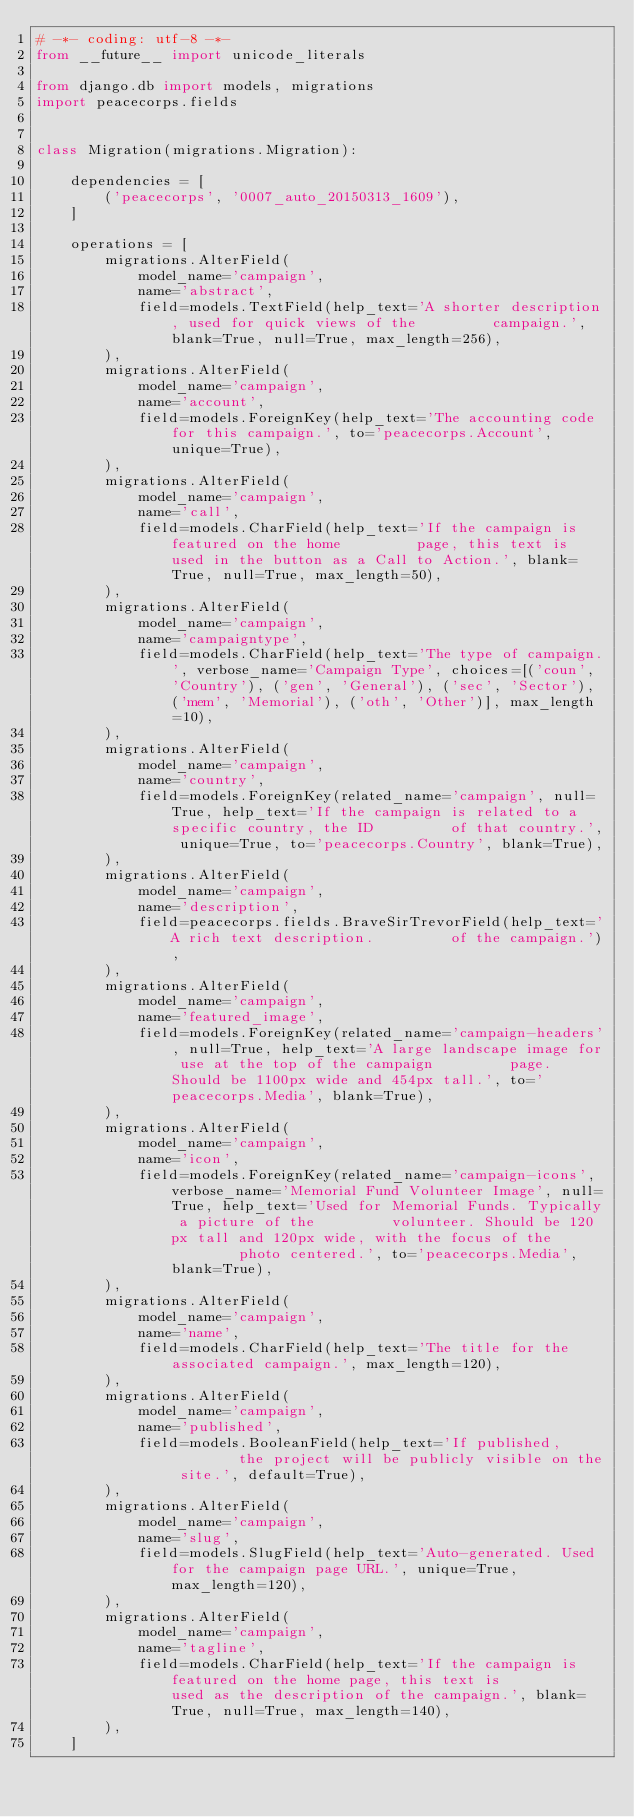<code> <loc_0><loc_0><loc_500><loc_500><_Python_># -*- coding: utf-8 -*-
from __future__ import unicode_literals

from django.db import models, migrations
import peacecorps.fields


class Migration(migrations.Migration):

    dependencies = [
        ('peacecorps', '0007_auto_20150313_1609'),
    ]

    operations = [
        migrations.AlterField(
            model_name='campaign',
            name='abstract',
            field=models.TextField(help_text='A shorter description, used for quick views of the         campaign.', blank=True, null=True, max_length=256),
        ),
        migrations.AlterField(
            model_name='campaign',
            name='account',
            field=models.ForeignKey(help_text='The accounting code for this campaign.', to='peacecorps.Account', unique=True),
        ),
        migrations.AlterField(
            model_name='campaign',
            name='call',
            field=models.CharField(help_text='If the campaign is featured on the home         page, this text is used in the button as a Call to Action.', blank=True, null=True, max_length=50),
        ),
        migrations.AlterField(
            model_name='campaign',
            name='campaigntype',
            field=models.CharField(help_text='The type of campaign.', verbose_name='Campaign Type', choices=[('coun', 'Country'), ('gen', 'General'), ('sec', 'Sector'), ('mem', 'Memorial'), ('oth', 'Other')], max_length=10),
        ),
        migrations.AlterField(
            model_name='campaign',
            name='country',
            field=models.ForeignKey(related_name='campaign', null=True, help_text='If the campaign is related to a specific country, the ID         of that country.', unique=True, to='peacecorps.Country', blank=True),
        ),
        migrations.AlterField(
            model_name='campaign',
            name='description',
            field=peacecorps.fields.BraveSirTrevorField(help_text='A rich text description.         of the campaign.'),
        ),
        migrations.AlterField(
            model_name='campaign',
            name='featured_image',
            field=models.ForeignKey(related_name='campaign-headers', null=True, help_text='A large landscape image for use at the top of the campaign         page. Should be 1100px wide and 454px tall.', to='peacecorps.Media', blank=True),
        ),
        migrations.AlterField(
            model_name='campaign',
            name='icon',
            field=models.ForeignKey(related_name='campaign-icons', verbose_name='Memorial Fund Volunteer Image', null=True, help_text='Used for Memorial Funds. Typically a picture of the         volunteer. Should be 120px tall and 120px wide, with the focus of the         photo centered.', to='peacecorps.Media', blank=True),
        ),
        migrations.AlterField(
            model_name='campaign',
            name='name',
            field=models.CharField(help_text='The title for the associated campaign.', max_length=120),
        ),
        migrations.AlterField(
            model_name='campaign',
            name='published',
            field=models.BooleanField(help_text='If published,         the project will be publicly visible on the site.', default=True),
        ),
        migrations.AlterField(
            model_name='campaign',
            name='slug',
            field=models.SlugField(help_text='Auto-generated. Used for the campaign page URL.', unique=True, max_length=120),
        ),
        migrations.AlterField(
            model_name='campaign',
            name='tagline',
            field=models.CharField(help_text='If the campaign is featured on the home page, this text is         used as the description of the campaign.', blank=True, null=True, max_length=140),
        ),
    ]
</code> 